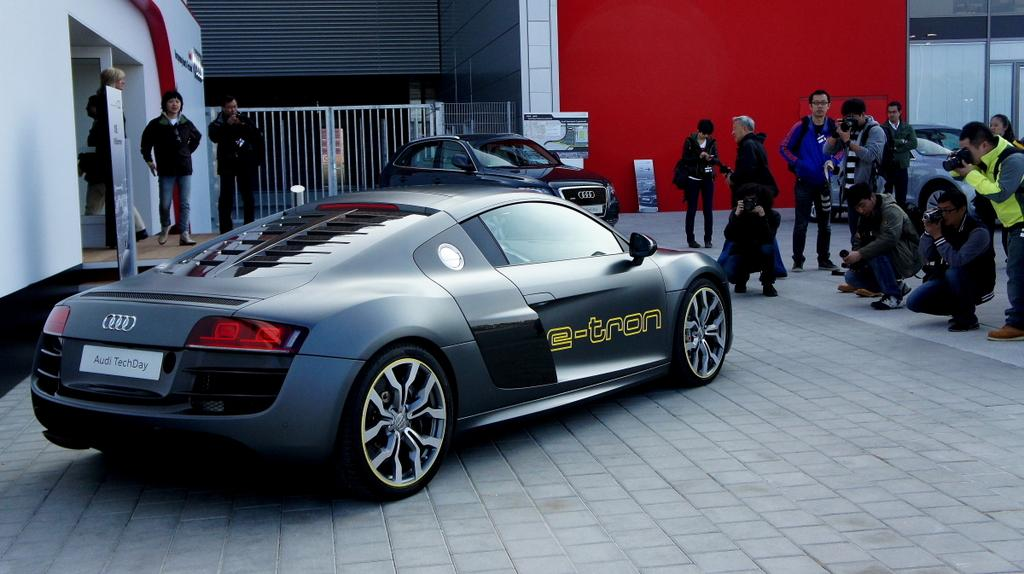What objects are on the floor in the image? There are motor vehicles on the floor. What can be seen in the background of the image? There are walls, a grill, and persons visible in the background of the image. How many rabbits can be seen interacting with the grill in the image? There are no rabbits present in the image, and therefore no interaction with the grill can be observed. 